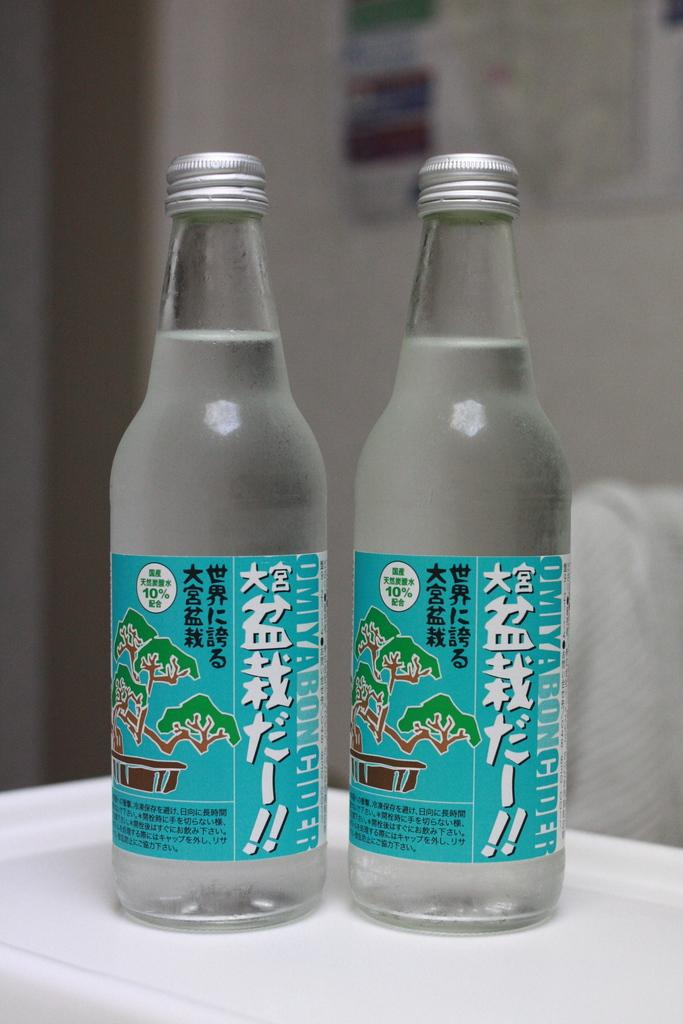<image>
Create a compact narrative representing the image presented. Two bottles of clear liquid with 10% on the labels. 